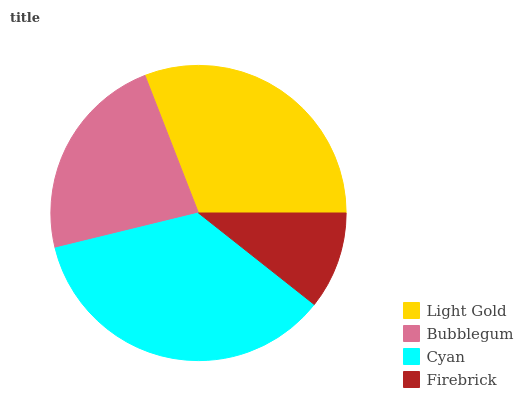Is Firebrick the minimum?
Answer yes or no. Yes. Is Cyan the maximum?
Answer yes or no. Yes. Is Bubblegum the minimum?
Answer yes or no. No. Is Bubblegum the maximum?
Answer yes or no. No. Is Light Gold greater than Bubblegum?
Answer yes or no. Yes. Is Bubblegum less than Light Gold?
Answer yes or no. Yes. Is Bubblegum greater than Light Gold?
Answer yes or no. No. Is Light Gold less than Bubblegum?
Answer yes or no. No. Is Light Gold the high median?
Answer yes or no. Yes. Is Bubblegum the low median?
Answer yes or no. Yes. Is Bubblegum the high median?
Answer yes or no. No. Is Cyan the low median?
Answer yes or no. No. 